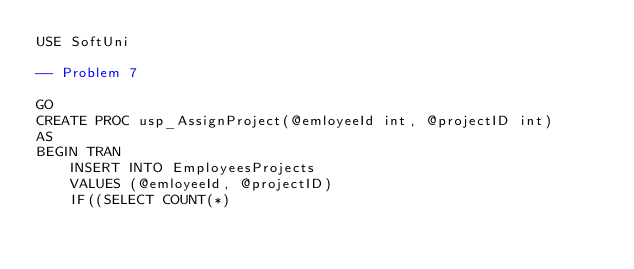<code> <loc_0><loc_0><loc_500><loc_500><_SQL_>USE SoftUni

-- Problem 7

GO
CREATE PROC usp_AssignProject(@emloyeeId int, @projectID int)
AS
BEGIN TRAN
    INSERT INTO EmployeesProjects
    VALUES (@emloyeeId, @projectID)
    IF((SELECT COUNT(*) </code> 